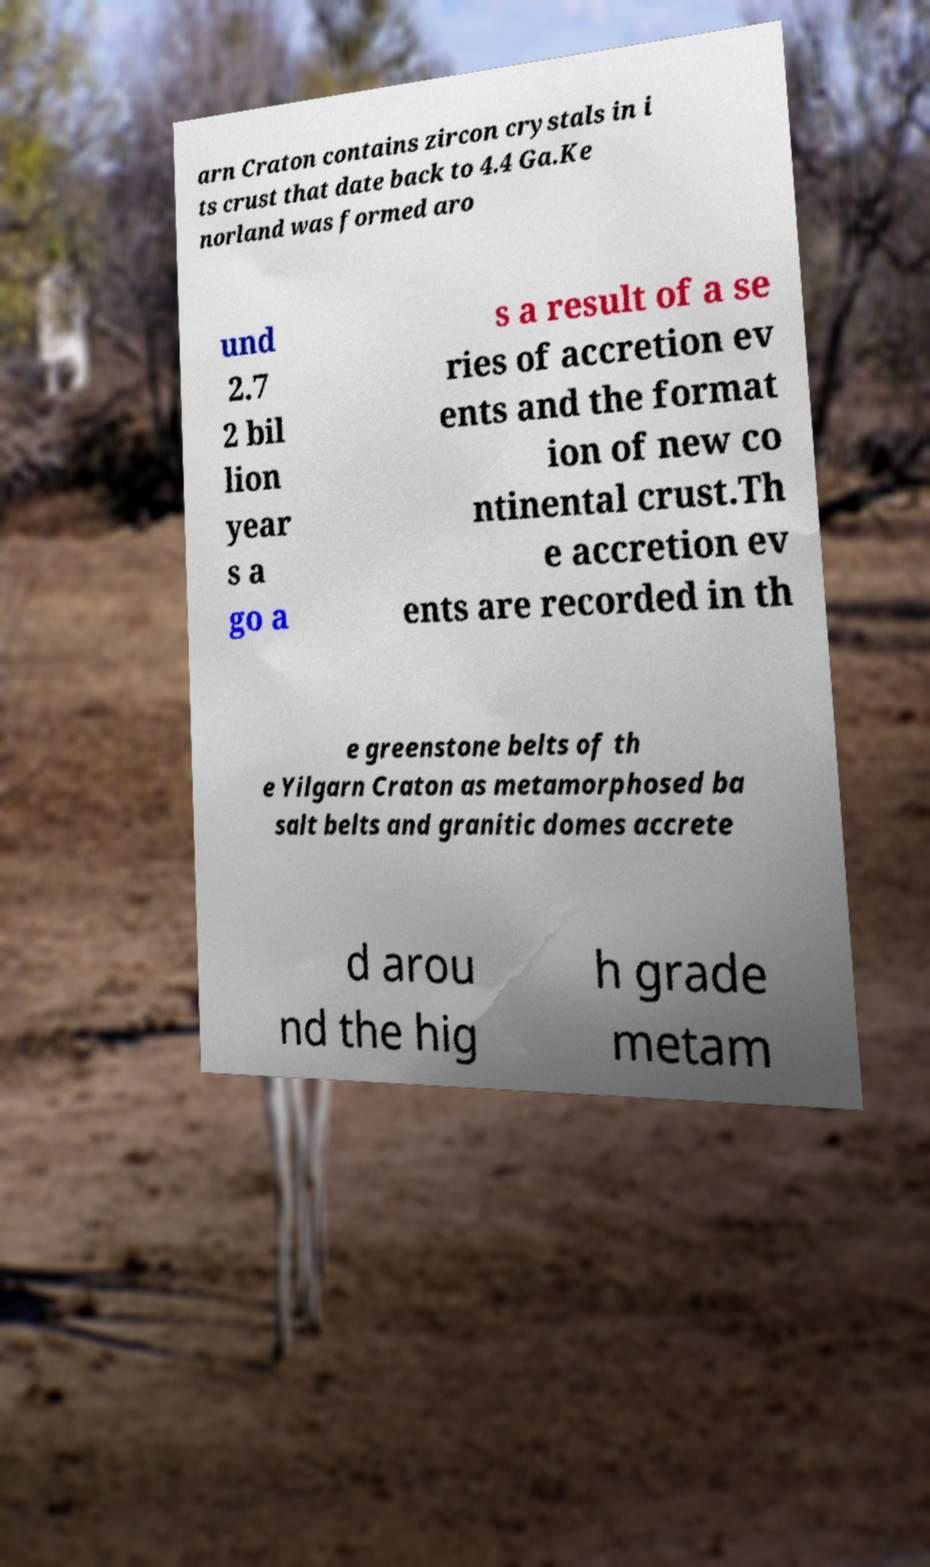Please read and relay the text visible in this image. What does it say? arn Craton contains zircon crystals in i ts crust that date back to 4.4 Ga.Ke norland was formed aro und 2.7 2 bil lion year s a go a s a result of a se ries of accretion ev ents and the format ion of new co ntinental crust.Th e accretion ev ents are recorded in th e greenstone belts of th e Yilgarn Craton as metamorphosed ba salt belts and granitic domes accrete d arou nd the hig h grade metam 